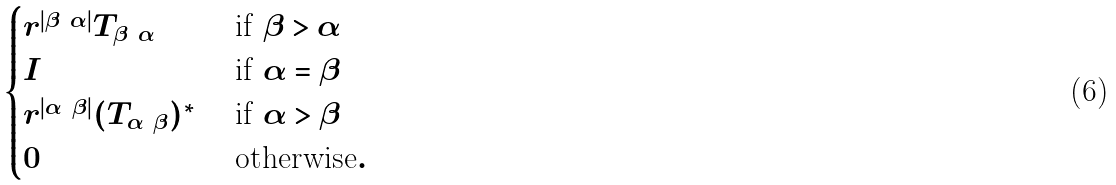Convert formula to latex. <formula><loc_0><loc_0><loc_500><loc_500>\begin{cases} r ^ { | \beta \ \alpha | } T _ { \beta \ \alpha } & \text { if } \beta > \alpha \\ I & \text { if } \alpha = \beta \\ r ^ { | \alpha \ \beta | } ( T _ { \alpha \ \beta } ) ^ { * } & \text { if } \alpha > \beta \\ 0 \quad & \text { otherwise} . \end{cases}</formula> 